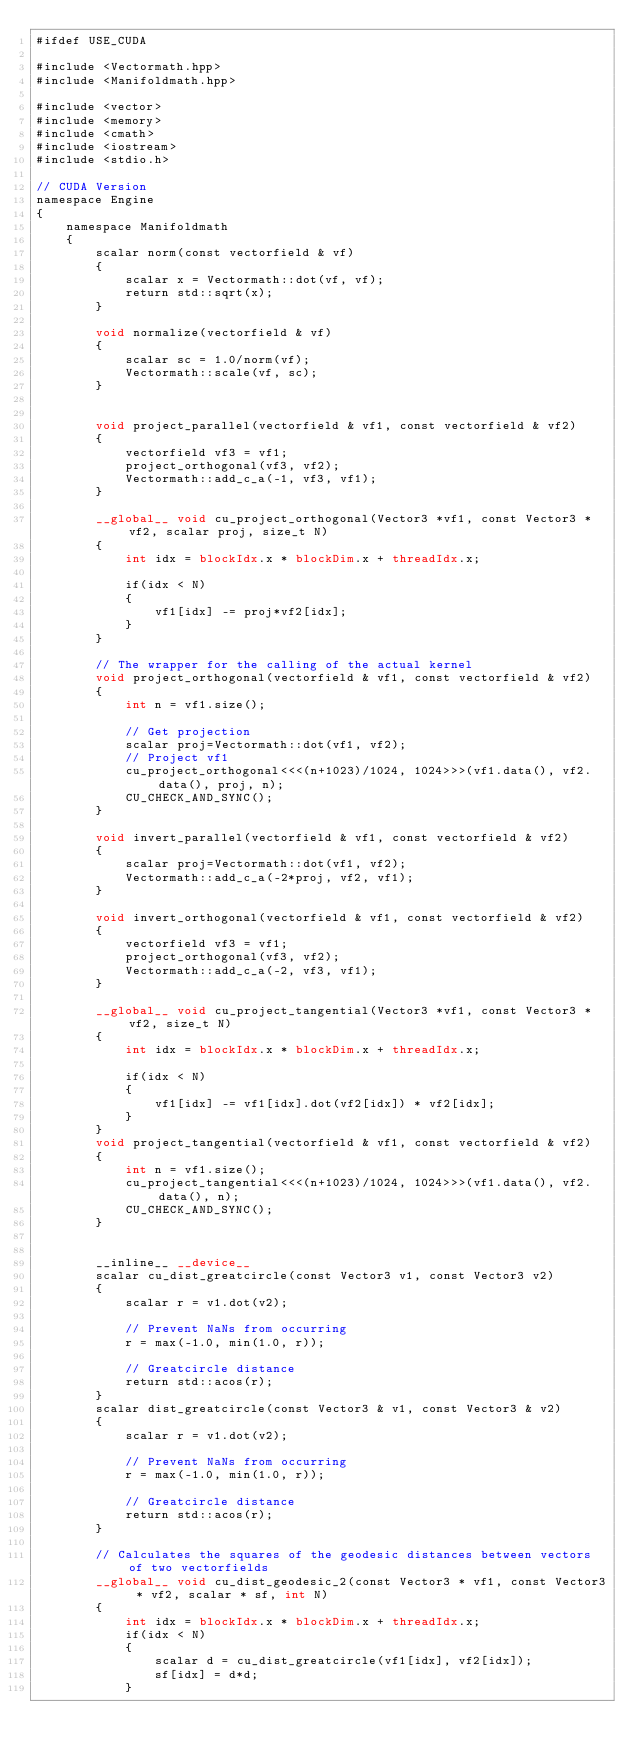Convert code to text. <code><loc_0><loc_0><loc_500><loc_500><_Cuda_>#ifdef USE_CUDA

#include <Vectormath.hpp>
#include <Manifoldmath.hpp>

#include <vector>
#include <memory>
#include <cmath>
#include <iostream>
#include <stdio.h>

// CUDA Version
namespace Engine
{
    namespace Manifoldmath
    {
        scalar norm(const vectorfield & vf)
        {
            scalar x = Vectormath::dot(vf, vf);
            return std::sqrt(x);
        }

        void normalize(vectorfield & vf)
        {
            scalar sc = 1.0/norm(vf);
            Vectormath::scale(vf, sc);
        }


        void project_parallel(vectorfield & vf1, const vectorfield & vf2)
        {
            vectorfield vf3 = vf1;
            project_orthogonal(vf3, vf2);
            Vectormath::add_c_a(-1, vf3, vf1);
        }

        __global__ void cu_project_orthogonal(Vector3 *vf1, const Vector3 *vf2, scalar proj, size_t N)
        {
            int idx = blockIdx.x * blockDim.x + threadIdx.x;

            if(idx < N)
            {
                vf1[idx] -= proj*vf2[idx];
            }
        }

        // The wrapper for the calling of the actual kernel
        void project_orthogonal(vectorfield & vf1, const vectorfield & vf2)
        {
            int n = vf1.size();

            // Get projection
            scalar proj=Vectormath::dot(vf1, vf2);
            // Project vf1
            cu_project_orthogonal<<<(n+1023)/1024, 1024>>>(vf1.data(), vf2.data(), proj, n);
            CU_CHECK_AND_SYNC();
        }

        void invert_parallel(vectorfield & vf1, const vectorfield & vf2)
        {
            scalar proj=Vectormath::dot(vf1, vf2);
            Vectormath::add_c_a(-2*proj, vf2, vf1);
        }
        
        void invert_orthogonal(vectorfield & vf1, const vectorfield & vf2)
        {
            vectorfield vf3 = vf1;
            project_orthogonal(vf3, vf2);
            Vectormath::add_c_a(-2, vf3, vf1);
        }

        __global__ void cu_project_tangential(Vector3 *vf1, const Vector3 *vf2, size_t N)
        {
            int idx = blockIdx.x * blockDim.x + threadIdx.x;

            if(idx < N)
            {
                vf1[idx] -= vf1[idx].dot(vf2[idx]) * vf2[idx];
            }
        }
        void project_tangential(vectorfield & vf1, const vectorfield & vf2)
        {
            int n = vf1.size();
            cu_project_tangential<<<(n+1023)/1024, 1024>>>(vf1.data(), vf2.data(), n);
            CU_CHECK_AND_SYNC();
        }


        __inline__ __device__
        scalar cu_dist_greatcircle(const Vector3 v1, const Vector3 v2)
        {
            scalar r = v1.dot(v2);

            // Prevent NaNs from occurring
            r = max(-1.0, min(1.0, r));

            // Greatcircle distance
            return std::acos(r);
        }
        scalar dist_greatcircle(const Vector3 & v1, const Vector3 & v2)
        {
            scalar r = v1.dot(v2);

            // Prevent NaNs from occurring
            r = max(-1.0, min(1.0, r));

            // Greatcircle distance
            return std::acos(r);
        }

        // Calculates the squares of the geodesic distances between vectors of two vectorfields
        __global__ void cu_dist_geodesic_2(const Vector3 * vf1, const Vector3 * vf2, scalar * sf, int N)
        {
            int idx = blockIdx.x * blockDim.x + threadIdx.x;
            if(idx < N)
            {
                scalar d = cu_dist_greatcircle(vf1[idx], vf2[idx]);
                sf[idx] = d*d;
            }</code> 